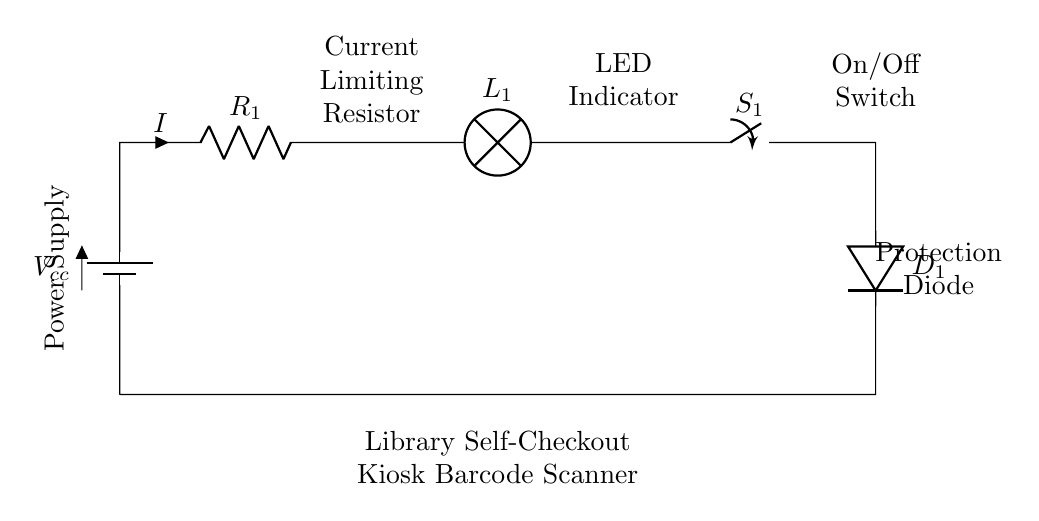What is the type of circuit shown? The circuit is a series circuit, which means that all components are connected in a single path for current flow. Each component must be connected in sequence, and the current flows through one component to get to the next.
Answer: series What component acts as a switch? The component labeled as S1 is the switch in the circuit that can open or close the circuit. When the switch is closed, it allows current to flow; when open, it interrupts the flow.
Answer: switch What is the purpose of the resistor in this circuit? The resistor, labeled R1, is used to limit the current flowing through the circuit to protect other components from excess current that could cause damage. It ensures that the current stays within safe limits.
Answer: current limiting How many main components are in the circuit? The circuit diagram includes five main components: a battery, a resistor, an LED indicator, a switch, and a diode. Each of these plays a vital role in the operation of the circuit.
Answer: five What type of indicator does this circuit employ? The circuit utilizes an LED as the indicator, which lights up when current flows through it. This indicates the operational status of the barcode scanner in the self-checkout kiosk.
Answer: LED What would happen if the diode was not included in the circuit? If the diode (D1) were omitted, there would be no protection against reverse current, which could potentially damage the components when the power supply is connected in reverse. Diodes allow current to flow in one direction only, preventing backflow.
Answer: damage risk What is the main function of this circuit? The primary function of this simple series circuit is to power the barcode scanner in the library's self-checkout kiosk, providing a visual indication of its operational state through the LED.
Answer: power scanner 